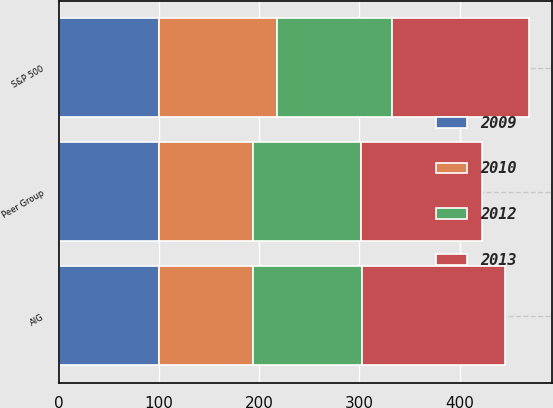<chart> <loc_0><loc_0><loc_500><loc_500><stacked_bar_chart><ecel><fcel>AIG<fcel>S&P 500<fcel>Peer Group<nl><fcel>2009<fcel>100<fcel>100<fcel>100<nl><fcel>2012<fcel>108.02<fcel>115.06<fcel>108.02<nl><fcel>2010<fcel>94.28<fcel>117.49<fcel>93.68<nl><fcel>2013<fcel>143.45<fcel>136.3<fcel>120.29<nl></chart> 